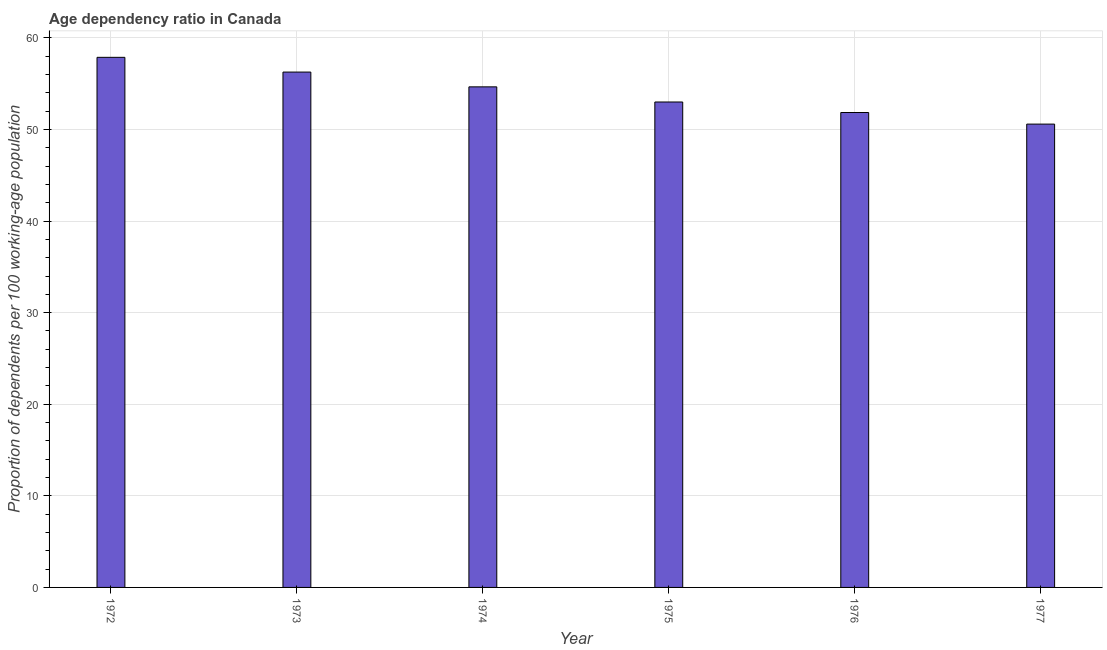What is the title of the graph?
Your response must be concise. Age dependency ratio in Canada. What is the label or title of the X-axis?
Offer a terse response. Year. What is the label or title of the Y-axis?
Your response must be concise. Proportion of dependents per 100 working-age population. What is the age dependency ratio in 1972?
Your response must be concise. 57.87. Across all years, what is the maximum age dependency ratio?
Provide a succinct answer. 57.87. Across all years, what is the minimum age dependency ratio?
Give a very brief answer. 50.58. What is the sum of the age dependency ratio?
Keep it short and to the point. 324.22. What is the difference between the age dependency ratio in 1975 and 1976?
Make the answer very short. 1.15. What is the average age dependency ratio per year?
Keep it short and to the point. 54.04. What is the median age dependency ratio?
Ensure brevity in your answer.  53.82. Is the age dependency ratio in 1972 less than that in 1973?
Keep it short and to the point. No. Is the difference between the age dependency ratio in 1972 and 1977 greater than the difference between any two years?
Offer a very short reply. Yes. What is the difference between the highest and the second highest age dependency ratio?
Keep it short and to the point. 1.61. What is the difference between the highest and the lowest age dependency ratio?
Provide a succinct answer. 7.29. In how many years, is the age dependency ratio greater than the average age dependency ratio taken over all years?
Offer a terse response. 3. How many years are there in the graph?
Offer a very short reply. 6. Are the values on the major ticks of Y-axis written in scientific E-notation?
Make the answer very short. No. What is the Proportion of dependents per 100 working-age population in 1972?
Keep it short and to the point. 57.87. What is the Proportion of dependents per 100 working-age population of 1973?
Give a very brief answer. 56.27. What is the Proportion of dependents per 100 working-age population of 1974?
Offer a very short reply. 54.65. What is the Proportion of dependents per 100 working-age population of 1975?
Your response must be concise. 53. What is the Proportion of dependents per 100 working-age population of 1976?
Ensure brevity in your answer.  51.85. What is the Proportion of dependents per 100 working-age population in 1977?
Provide a short and direct response. 50.58. What is the difference between the Proportion of dependents per 100 working-age population in 1972 and 1973?
Ensure brevity in your answer.  1.61. What is the difference between the Proportion of dependents per 100 working-age population in 1972 and 1974?
Provide a short and direct response. 3.22. What is the difference between the Proportion of dependents per 100 working-age population in 1972 and 1975?
Your answer should be very brief. 4.88. What is the difference between the Proportion of dependents per 100 working-age population in 1972 and 1976?
Your answer should be compact. 6.02. What is the difference between the Proportion of dependents per 100 working-age population in 1972 and 1977?
Provide a short and direct response. 7.29. What is the difference between the Proportion of dependents per 100 working-age population in 1973 and 1974?
Keep it short and to the point. 1.62. What is the difference between the Proportion of dependents per 100 working-age population in 1973 and 1975?
Your response must be concise. 3.27. What is the difference between the Proportion of dependents per 100 working-age population in 1973 and 1976?
Provide a short and direct response. 4.41. What is the difference between the Proportion of dependents per 100 working-age population in 1973 and 1977?
Your answer should be compact. 5.68. What is the difference between the Proportion of dependents per 100 working-age population in 1974 and 1975?
Keep it short and to the point. 1.65. What is the difference between the Proportion of dependents per 100 working-age population in 1974 and 1976?
Offer a terse response. 2.8. What is the difference between the Proportion of dependents per 100 working-age population in 1974 and 1977?
Keep it short and to the point. 4.07. What is the difference between the Proportion of dependents per 100 working-age population in 1975 and 1976?
Give a very brief answer. 1.15. What is the difference between the Proportion of dependents per 100 working-age population in 1975 and 1977?
Provide a short and direct response. 2.41. What is the difference between the Proportion of dependents per 100 working-age population in 1976 and 1977?
Ensure brevity in your answer.  1.27. What is the ratio of the Proportion of dependents per 100 working-age population in 1972 to that in 1974?
Make the answer very short. 1.06. What is the ratio of the Proportion of dependents per 100 working-age population in 1972 to that in 1975?
Your answer should be compact. 1.09. What is the ratio of the Proportion of dependents per 100 working-age population in 1972 to that in 1976?
Your response must be concise. 1.12. What is the ratio of the Proportion of dependents per 100 working-age population in 1972 to that in 1977?
Provide a short and direct response. 1.14. What is the ratio of the Proportion of dependents per 100 working-age population in 1973 to that in 1974?
Provide a short and direct response. 1.03. What is the ratio of the Proportion of dependents per 100 working-age population in 1973 to that in 1975?
Your answer should be very brief. 1.06. What is the ratio of the Proportion of dependents per 100 working-age population in 1973 to that in 1976?
Give a very brief answer. 1.08. What is the ratio of the Proportion of dependents per 100 working-age population in 1973 to that in 1977?
Offer a very short reply. 1.11. What is the ratio of the Proportion of dependents per 100 working-age population in 1974 to that in 1975?
Provide a short and direct response. 1.03. What is the ratio of the Proportion of dependents per 100 working-age population in 1974 to that in 1976?
Your answer should be compact. 1.05. What is the ratio of the Proportion of dependents per 100 working-age population in 1974 to that in 1977?
Give a very brief answer. 1.08. What is the ratio of the Proportion of dependents per 100 working-age population in 1975 to that in 1976?
Provide a succinct answer. 1.02. What is the ratio of the Proportion of dependents per 100 working-age population in 1975 to that in 1977?
Your response must be concise. 1.05. 